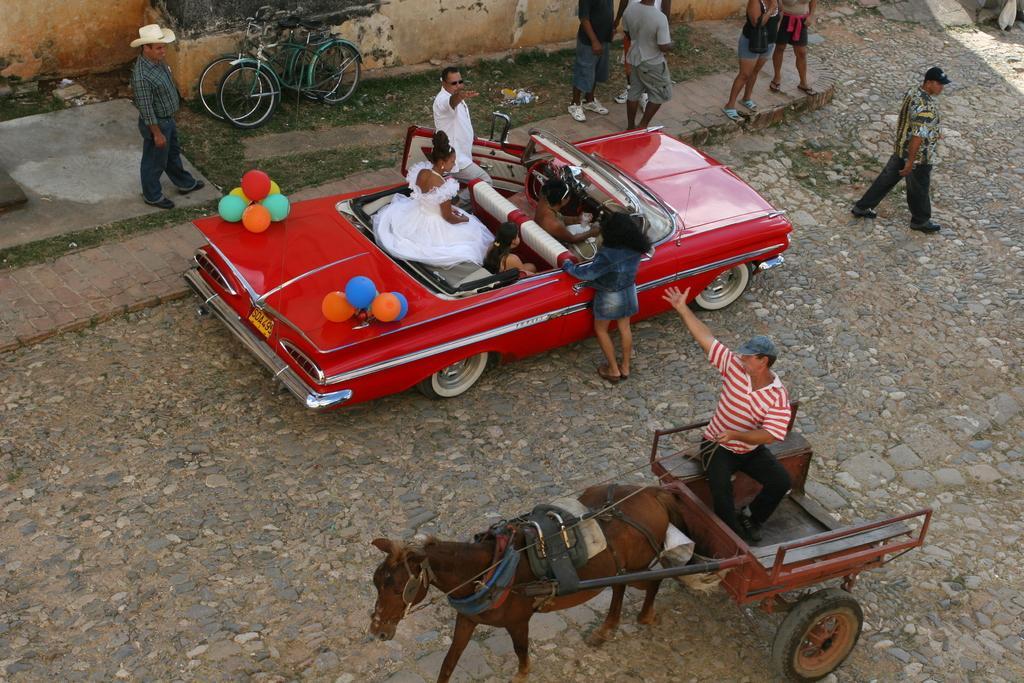Describe this image in one or two sentences. There are three ladies sitting in a red car and there are two person standing on the either side of the car and there are group of people in front of the car and there is persons sitting on a horse vehicle. 